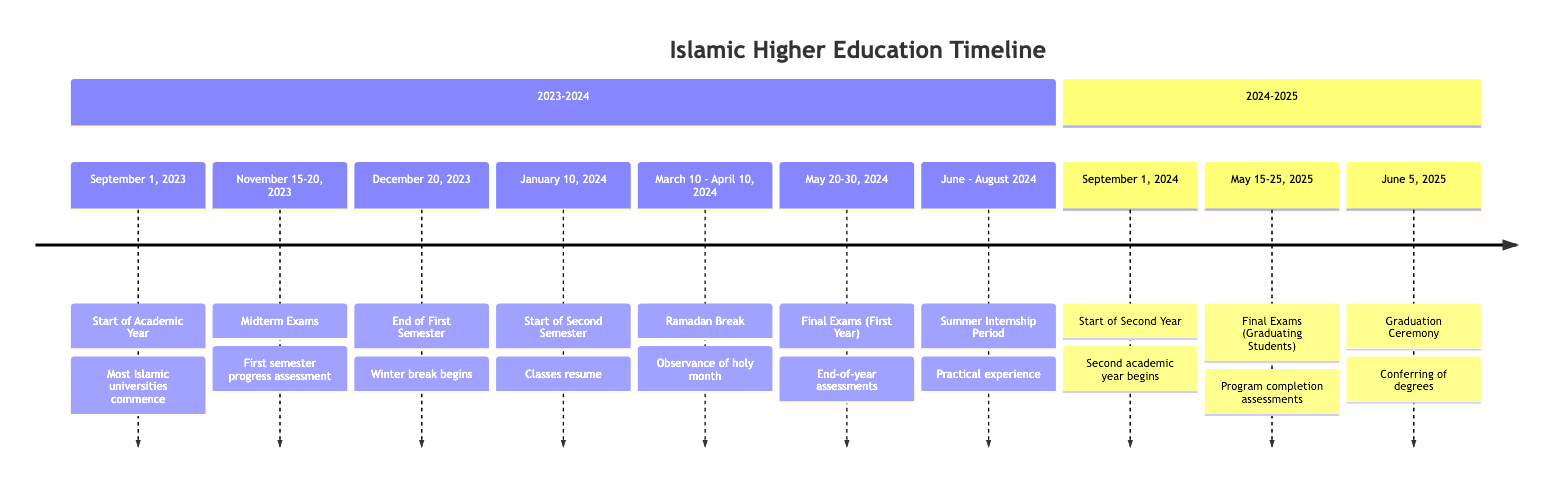What milestone occurs on September 1, 2023? The diagram states that "Start of the Academic Year" is the milestone that occurs on this date.
Answer: Start of the Academic Year What are the dates for Midterm Exams? According to the timeline, Midterm Exams are scheduled between November 15 and November 20, 2023.
Answer: November 15-20, 2023 How long is the Ramadan Break? The timeline shows that the Ramadan Break lasts from March 10 to April 10, 2024, which is a total of 31 days.
Answer: 31 days When does the Summer Internship Period start? Looking at the diagram, the Summer Internship Period starts in June 2024 and continues through August 2024.
Answer: June - August 2024 What milestone follows the End of the First Semester? The diagram indicates that the "Start of Second Semester" follows the End of the First Semester on December 20, 2023.
Answer: Start of Second Semester What is the date of the Graduation Ceremony? The timeline specifies that the Graduation Ceremony will take place on June 5, 2025.
Answer: June 5, 2025 Which milestone occurs just before Final Exams for Graduating Students? Reviewing the timeline, the milestone that occurs just before Final Exams for Graduating Students (May 15-25, 2025) is the "Start of the Academic Year (Second Year)" on September 1, 2024.
Answer: Start of the Academic Year (Second Year) How many total major milestones are listed for the 2023-2024 academic year? Counting the milestones from September 1, 2023, to the end of the Summer Internship Period in 2024, there are seven major milestones in this specific academic year.
Answer: 7 What important event follows the Final Exams for First Year students? The timeline states that the event following the Final Exams (May 20-30, 2024) is the Summer Internship Period starting in June 2024.
Answer: Summer Internship Period 